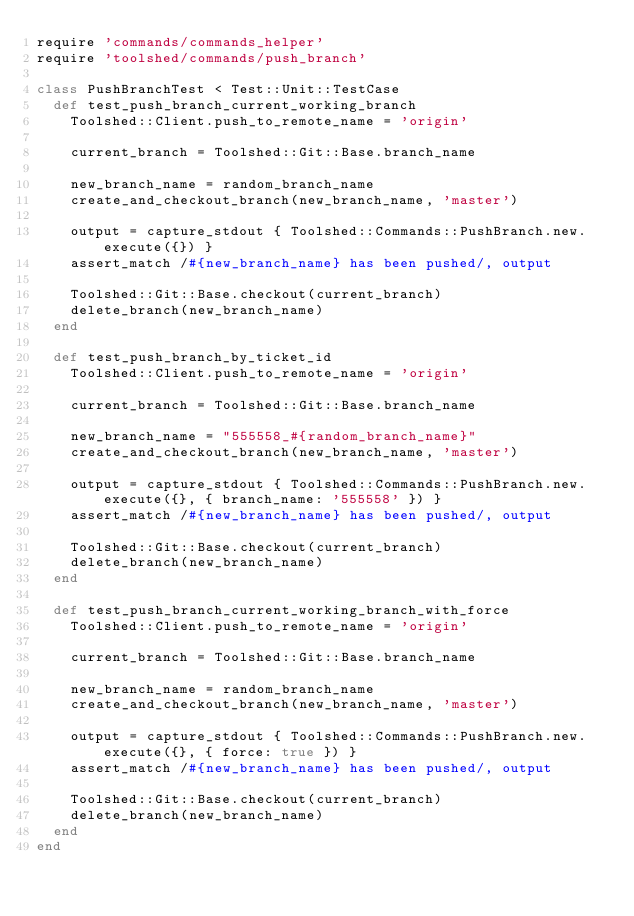Convert code to text. <code><loc_0><loc_0><loc_500><loc_500><_Ruby_>require 'commands/commands_helper'
require 'toolshed/commands/push_branch'

class PushBranchTest < Test::Unit::TestCase
  def test_push_branch_current_working_branch
    Toolshed::Client.push_to_remote_name = 'origin'

    current_branch = Toolshed::Git::Base.branch_name

    new_branch_name = random_branch_name
    create_and_checkout_branch(new_branch_name, 'master')

    output = capture_stdout { Toolshed::Commands::PushBranch.new.execute({}) }
    assert_match /#{new_branch_name} has been pushed/, output

    Toolshed::Git::Base.checkout(current_branch)
    delete_branch(new_branch_name)
  end

  def test_push_branch_by_ticket_id
    Toolshed::Client.push_to_remote_name = 'origin'

    current_branch = Toolshed::Git::Base.branch_name

    new_branch_name = "555558_#{random_branch_name}"
    create_and_checkout_branch(new_branch_name, 'master')

    output = capture_stdout { Toolshed::Commands::PushBranch.new.execute({}, { branch_name: '555558' }) }
    assert_match /#{new_branch_name} has been pushed/, output

    Toolshed::Git::Base.checkout(current_branch)
    delete_branch(new_branch_name)
  end

  def test_push_branch_current_working_branch_with_force
    Toolshed::Client.push_to_remote_name = 'origin'

    current_branch = Toolshed::Git::Base.branch_name

    new_branch_name = random_branch_name
    create_and_checkout_branch(new_branch_name, 'master')

    output = capture_stdout { Toolshed::Commands::PushBranch.new.execute({}, { force: true }) }
    assert_match /#{new_branch_name} has been pushed/, output

    Toolshed::Git::Base.checkout(current_branch)
    delete_branch(new_branch_name)
  end
end
</code> 